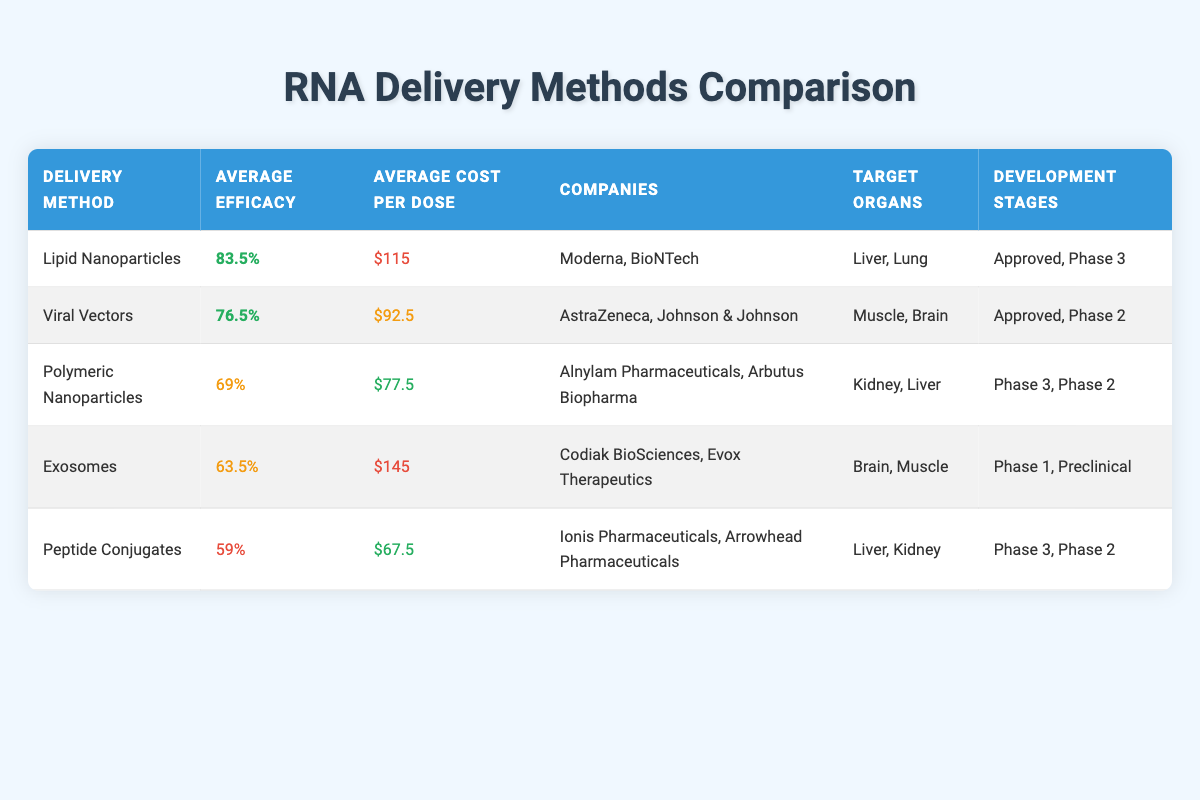What is the average efficacy of Lipid Nanoparticles? By looking at the efficacy values for Lipid Nanoparticles provided in the table, which are 85% (Moderna) and 82% (BioNTech), we calculate the average by summing these two values (85 + 82) and dividing by 2. Thus, (85 + 82) / 2 = 83.5%
Answer: 83.5% Which delivery method has the lowest cost per dose? The table lists the cost per dose for each delivery method. By comparing these values, we see that Peptide Conjugates have the lowest cost at $67.5.
Answer: Peptide Conjugates Are there any delivery methods that are in Phase 3 development? To answer this, we need to survey the "Development Stages" column in the table. We find that both Lipid Nanoparticles and Polymeric Nanoparticles are mentioned in Phase 3.
Answer: Yes What is the average cost per dose for Viral Vectors? For Viral Vectors, the cost per dose values are $95 (AstraZeneca) and $90 (Johnson & Johnson). We calculate the average by adding these two amounts (95 + 90) and dividing by 2. Therefore, (95 + 90) / 2 = 92.5
Answer: 92.5 Which delivery method has the highest efficacy and what is the associated cost per dose? Upon comparing the efficacy values from the table, Lipid Nanoparticles yield the highest efficacy at 85%. The associated cost for this delivery method from Moderna is $120.
Answer: Lipid Nanoparticles, $120 Do any delivery methods target the brain? We check the "Target Organs" column in the table for delivery methods targeting the brain. Both Viral Vectors and Exosomes are listed as targeting the brain.
Answer: Yes What is the difference in average efficacy between Exosomes and Polymeric Nanoparticles? First, we find the efficacy for Exosomes (63.5%) and Polymeric Nanoparticles (69%). To find the difference, we subtract the average efficacy of Exosomes from that of Polymeric Nanoparticles: 69 - 63.5 = 5.5.
Answer: 5.5% How many companies are involved in the delivery of Lipid Nanoparticles? In the "Companies" column associated with Lipid Nanoparticles, we see two entries: Moderna and BioNTech. Thus, there are two companies.
Answer: 2 Is the average cost per dose of Exosomes higher than that of Polymeric Nanoparticles? The average cost per dose for Exosomes is $145, while for Polymeric Nanoparticles it is $77.5. Since $145 is greater than $77.5, we conclude that the average cost for Exosomes is indeed higher.
Answer: Yes 